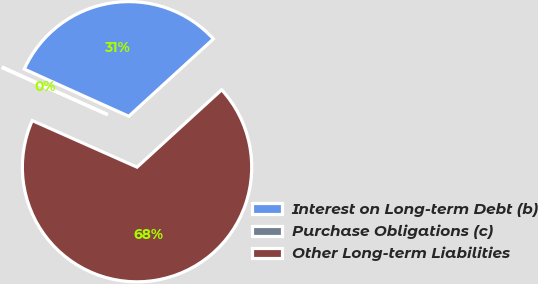Convert chart. <chart><loc_0><loc_0><loc_500><loc_500><pie_chart><fcel>Interest on Long-term Debt (b)<fcel>Purchase Obligations (c)<fcel>Other Long-term Liabilities<nl><fcel>31.46%<fcel>0.09%<fcel>68.44%<nl></chart> 